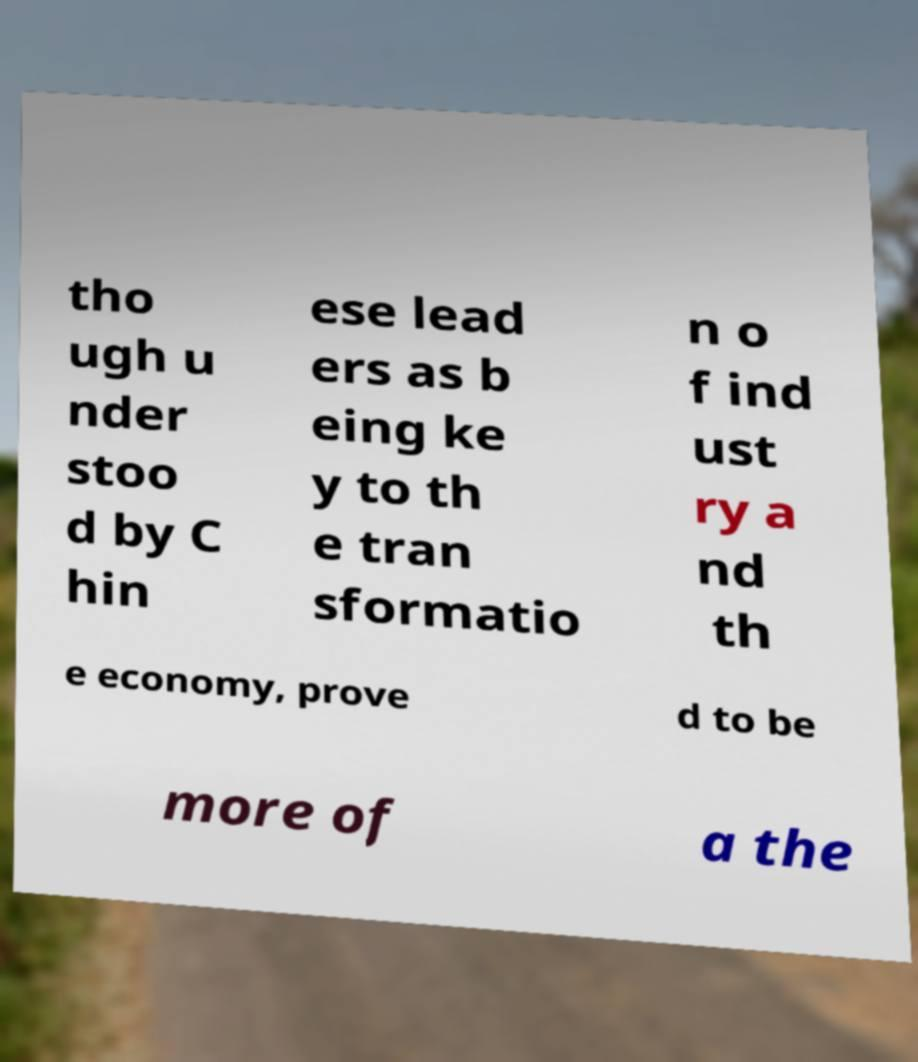Could you assist in decoding the text presented in this image and type it out clearly? tho ugh u nder stoo d by C hin ese lead ers as b eing ke y to th e tran sformatio n o f ind ust ry a nd th e economy, prove d to be more of a the 